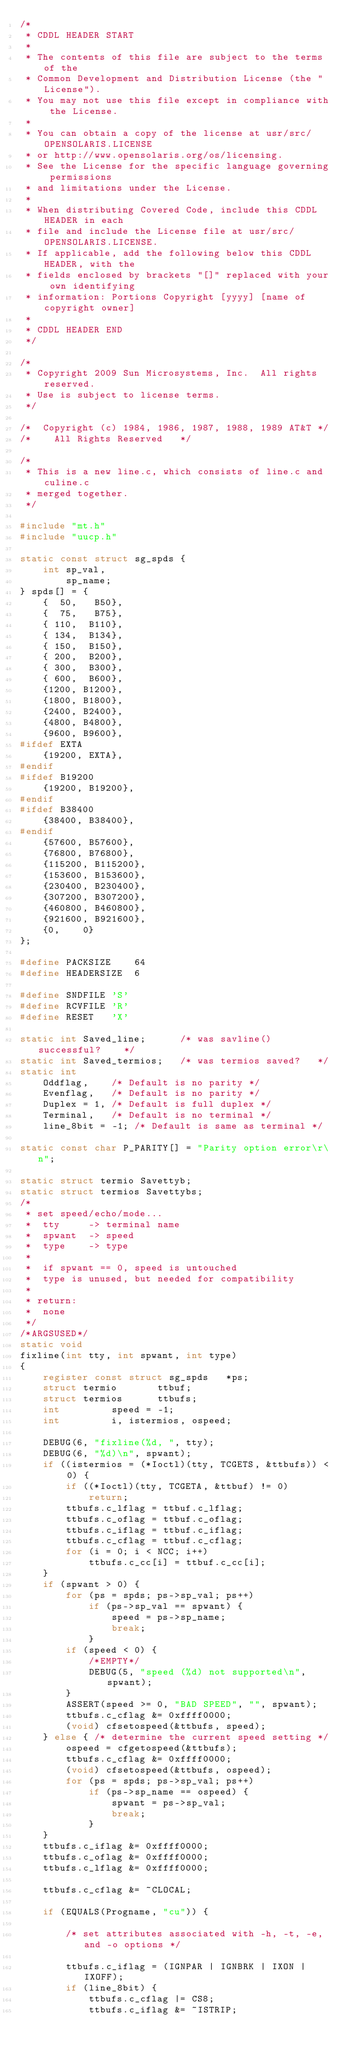Convert code to text. <code><loc_0><loc_0><loc_500><loc_500><_C_>/*
 * CDDL HEADER START
 *
 * The contents of this file are subject to the terms of the
 * Common Development and Distribution License (the "License").
 * You may not use this file except in compliance with the License.
 *
 * You can obtain a copy of the license at usr/src/OPENSOLARIS.LICENSE
 * or http://www.opensolaris.org/os/licensing.
 * See the License for the specific language governing permissions
 * and limitations under the License.
 *
 * When distributing Covered Code, include this CDDL HEADER in each
 * file and include the License file at usr/src/OPENSOLARIS.LICENSE.
 * If applicable, add the following below this CDDL HEADER, with the
 * fields enclosed by brackets "[]" replaced with your own identifying
 * information: Portions Copyright [yyyy] [name of copyright owner]
 *
 * CDDL HEADER END
 */

/*
 * Copyright 2009 Sun Microsystems, Inc.  All rights reserved.
 * Use is subject to license terms.
 */

/*	Copyright (c) 1984, 1986, 1987, 1988, 1989 AT&T	*/
/*	  All Rights Reserved  	*/

/*
 * This is a new line.c, which consists of line.c and culine.c
 * merged together.
 */

#include "mt.h"
#include "uucp.h"

static const struct sg_spds {
	int	sp_val,
		sp_name;
} spds[] = {
	{  50,   B50},
	{  75,   B75},
	{ 110,  B110},
	{ 134,  B134},
	{ 150,  B150},
	{ 200,  B200},
	{ 300,  B300},
	{ 600,  B600},
	{1200, B1200},
	{1800, B1800},
	{2400, B2400},
	{4800, B4800},
	{9600, B9600},
#ifdef EXTA
	{19200,	EXTA},
#endif
#ifdef B19200
	{19200,	B19200},
#endif
#ifdef B38400
	{38400,	B38400},
#endif
	{57600, B57600},
	{76800, B76800},
	{115200, B115200},
	{153600, B153600},
	{230400, B230400},
	{307200, B307200},
	{460800, B460800},
	{921600, B921600},
	{0,    0}
};

#define	PACKSIZE	64
#define	HEADERSIZE	6

#define	SNDFILE	'S'
#define	RCVFILE 'R'
#define	RESET	'X'

static int Saved_line;		/* was savline() successful?	*/
static int Saved_termios;	/* was termios saved?	*/
static int
	Oddflag,	/* Default is no parity */
	Evenflag,	/* Default is no parity */
	Duplex = 1,	/* Default is full duplex */
	Terminal,	/* Default is no terminal */
	line_8bit = -1;	/* Default is same as terminal */

static const char P_PARITY[] = "Parity option error\r\n";

static struct termio Savettyb;
static struct termios Savettybs;
/*
 * set speed/echo/mode...
 *	tty 	-> terminal name
 *	spwant 	-> speed
 *	type	-> type
 *
 *	if spwant == 0, speed is untouched
 *	type is unused, but needed for compatibility
 *
 * return:
 *	none
 */
/*ARGSUSED*/
static void
fixline(int tty, int spwant, int type)
{
	register const struct sg_spds	*ps;
	struct termio		ttbuf;
	struct termios		ttbufs;
	int			speed = -1;
	int			i, istermios, ospeed;

	DEBUG(6, "fixline(%d, ", tty);
	DEBUG(6, "%d)\n", spwant);
	if ((istermios = (*Ioctl)(tty, TCGETS, &ttbufs)) < 0) {
		if ((*Ioctl)(tty, TCGETA, &ttbuf) != 0)
			return;
		ttbufs.c_lflag = ttbuf.c_lflag;
		ttbufs.c_oflag = ttbuf.c_oflag;
		ttbufs.c_iflag = ttbuf.c_iflag;
		ttbufs.c_cflag = ttbuf.c_cflag;
		for (i = 0; i < NCC; i++)
			ttbufs.c_cc[i] = ttbuf.c_cc[i];
	}
	if (spwant > 0) {
		for (ps = spds; ps->sp_val; ps++)
			if (ps->sp_val == spwant) {
				speed = ps->sp_name;
				break;
			}
		if (speed < 0) {
			/*EMPTY*/
			DEBUG(5, "speed (%d) not supported\n", spwant);
		}
		ASSERT(speed >= 0, "BAD SPEED", "", spwant);
		ttbufs.c_cflag &= 0xffff0000;
		(void) cfsetospeed(&ttbufs, speed);
	} else { /* determine the current speed setting */
		ospeed = cfgetospeed(&ttbufs);
		ttbufs.c_cflag &= 0xffff0000;
		(void) cfsetospeed(&ttbufs, ospeed);
		for (ps = spds; ps->sp_val; ps++)
			if (ps->sp_name == ospeed) {
				spwant = ps->sp_val;
				break;
			}
	}
	ttbufs.c_iflag &= 0xffff0000;
	ttbufs.c_oflag &= 0xffff0000;
	ttbufs.c_lflag &= 0xffff0000;

	ttbufs.c_cflag &= ~CLOCAL;

	if (EQUALS(Progname, "cu")) {

		/* set attributes associated with -h, -t, -e, and -o options */

		ttbufs.c_iflag = (IGNPAR | IGNBRK | IXON | IXOFF);
		if (line_8bit) {
			ttbufs.c_cflag |= CS8;
			ttbufs.c_iflag &= ~ISTRIP;</code> 